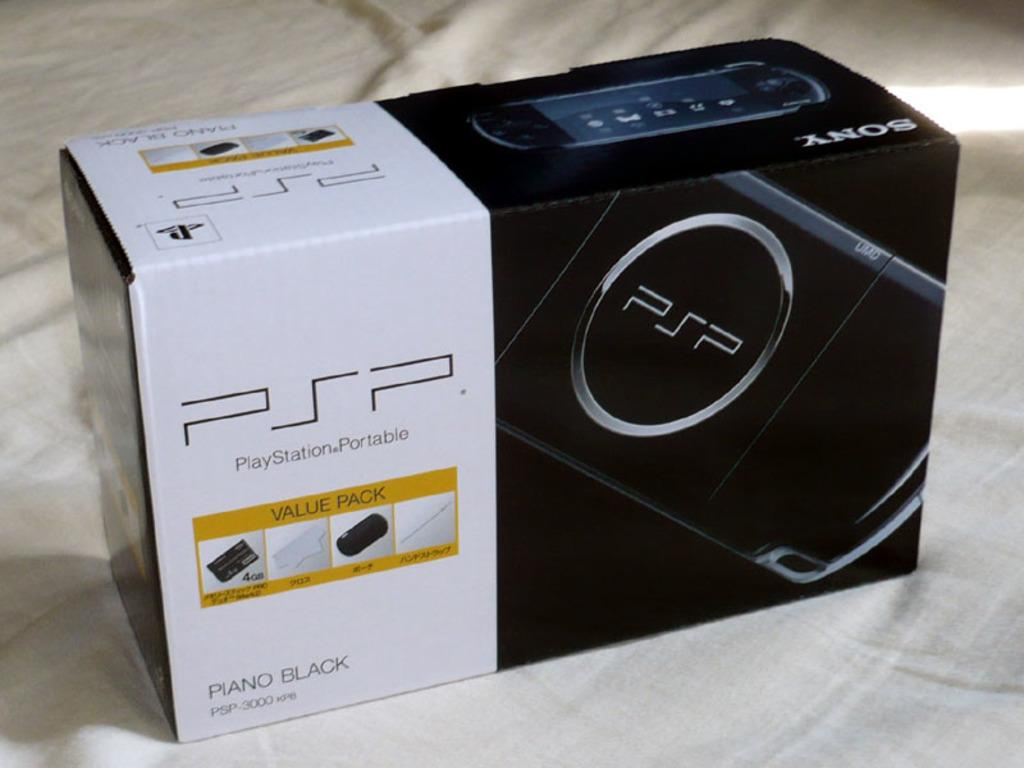Provide a one-sentence caption for the provided image. A black and white rectangular box holding a PSP (PlayStationPortable) in the color of piano black. 